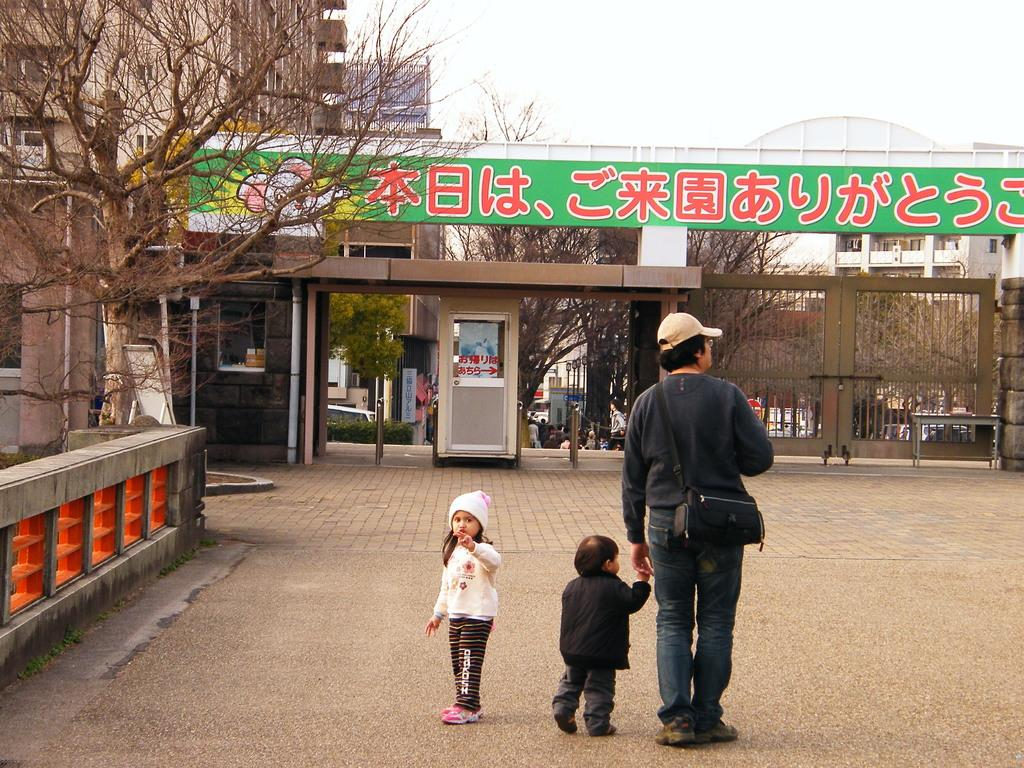How many people are in the image? There is a group of people in the image, but the exact number cannot be determined from the provided facts. What can be seen in the background of the image? There are buildings, trees, and a hoarding in the background of the image. What is located on the left side of the image? There are pipes on the left side of the image. What type of finger can be seen on the hoarding in the image? There are no fingers present on the hoarding in the image; it is a billboard or advertisement. 